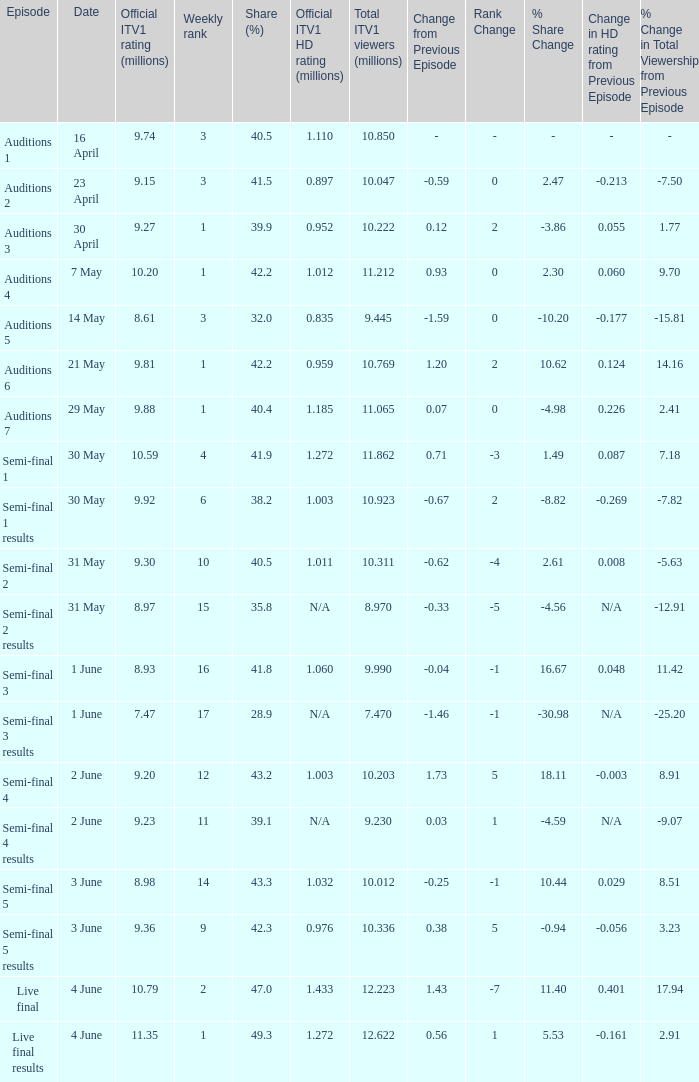Which episode had an official ITV1 HD rating of 1.185 million?  Auditions 7. 